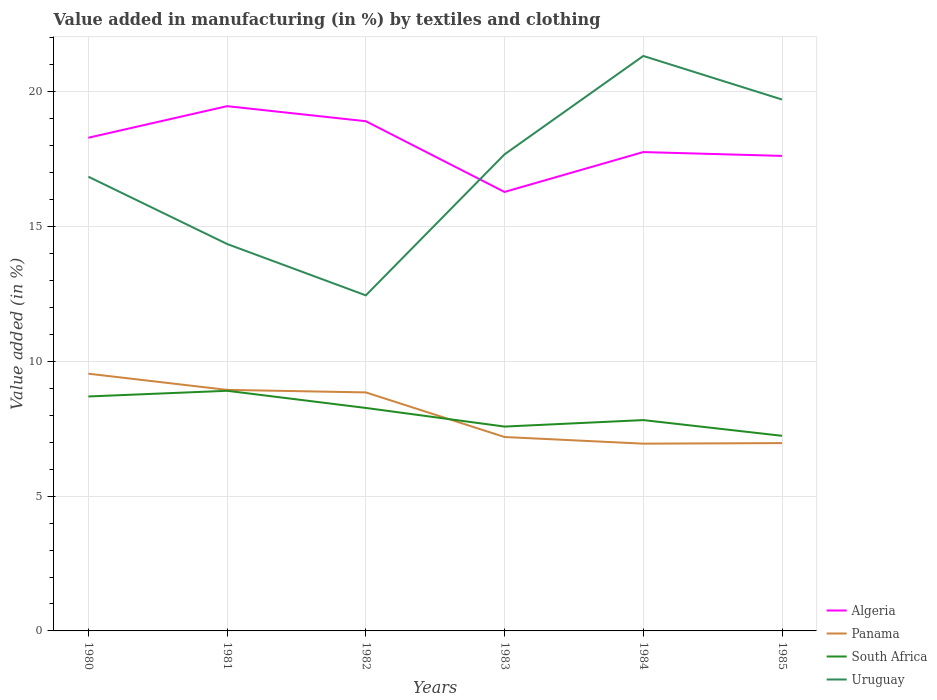Is the number of lines equal to the number of legend labels?
Provide a short and direct response. Yes. Across all years, what is the maximum percentage of value added in manufacturing by textiles and clothing in Algeria?
Offer a terse response. 16.29. In which year was the percentage of value added in manufacturing by textiles and clothing in South Africa maximum?
Provide a short and direct response. 1985. What is the total percentage of value added in manufacturing by textiles and clothing in Uruguay in the graph?
Your answer should be compact. 1.62. What is the difference between the highest and the second highest percentage of value added in manufacturing by textiles and clothing in Uruguay?
Provide a succinct answer. 8.88. What is the difference between two consecutive major ticks on the Y-axis?
Provide a succinct answer. 5. Does the graph contain any zero values?
Your response must be concise. No. Does the graph contain grids?
Your answer should be compact. Yes. How are the legend labels stacked?
Your response must be concise. Vertical. What is the title of the graph?
Offer a terse response. Value added in manufacturing (in %) by textiles and clothing. Does "European Union" appear as one of the legend labels in the graph?
Provide a succinct answer. No. What is the label or title of the Y-axis?
Keep it short and to the point. Value added (in %). What is the Value added (in %) of Algeria in 1980?
Offer a very short reply. 18.3. What is the Value added (in %) in Panama in 1980?
Offer a terse response. 9.54. What is the Value added (in %) of South Africa in 1980?
Ensure brevity in your answer.  8.7. What is the Value added (in %) of Uruguay in 1980?
Keep it short and to the point. 16.85. What is the Value added (in %) of Algeria in 1981?
Your response must be concise. 19.47. What is the Value added (in %) in Panama in 1981?
Make the answer very short. 8.94. What is the Value added (in %) of South Africa in 1981?
Your response must be concise. 8.91. What is the Value added (in %) of Uruguay in 1981?
Your response must be concise. 14.35. What is the Value added (in %) of Algeria in 1982?
Give a very brief answer. 18.91. What is the Value added (in %) in Panama in 1982?
Ensure brevity in your answer.  8.85. What is the Value added (in %) of South Africa in 1982?
Your answer should be very brief. 8.27. What is the Value added (in %) in Uruguay in 1982?
Ensure brevity in your answer.  12.45. What is the Value added (in %) of Algeria in 1983?
Keep it short and to the point. 16.29. What is the Value added (in %) of Panama in 1983?
Provide a succinct answer. 7.19. What is the Value added (in %) of South Africa in 1983?
Offer a very short reply. 7.58. What is the Value added (in %) of Uruguay in 1983?
Offer a terse response. 17.68. What is the Value added (in %) of Algeria in 1984?
Give a very brief answer. 17.76. What is the Value added (in %) of Panama in 1984?
Your response must be concise. 6.95. What is the Value added (in %) in South Africa in 1984?
Provide a succinct answer. 7.82. What is the Value added (in %) in Uruguay in 1984?
Your response must be concise. 21.33. What is the Value added (in %) of Algeria in 1985?
Make the answer very short. 17.62. What is the Value added (in %) of Panama in 1985?
Ensure brevity in your answer.  6.97. What is the Value added (in %) of South Africa in 1985?
Make the answer very short. 7.24. What is the Value added (in %) in Uruguay in 1985?
Provide a succinct answer. 19.71. Across all years, what is the maximum Value added (in %) in Algeria?
Keep it short and to the point. 19.47. Across all years, what is the maximum Value added (in %) in Panama?
Provide a succinct answer. 9.54. Across all years, what is the maximum Value added (in %) of South Africa?
Your response must be concise. 8.91. Across all years, what is the maximum Value added (in %) of Uruguay?
Your answer should be compact. 21.33. Across all years, what is the minimum Value added (in %) in Algeria?
Provide a short and direct response. 16.29. Across all years, what is the minimum Value added (in %) in Panama?
Your answer should be very brief. 6.95. Across all years, what is the minimum Value added (in %) of South Africa?
Keep it short and to the point. 7.24. Across all years, what is the minimum Value added (in %) of Uruguay?
Keep it short and to the point. 12.45. What is the total Value added (in %) in Algeria in the graph?
Give a very brief answer. 108.35. What is the total Value added (in %) in Panama in the graph?
Provide a succinct answer. 48.44. What is the total Value added (in %) of South Africa in the graph?
Offer a very short reply. 48.52. What is the total Value added (in %) in Uruguay in the graph?
Your answer should be very brief. 102.38. What is the difference between the Value added (in %) in Algeria in 1980 and that in 1981?
Ensure brevity in your answer.  -1.17. What is the difference between the Value added (in %) of Panama in 1980 and that in 1981?
Give a very brief answer. 0.6. What is the difference between the Value added (in %) in South Africa in 1980 and that in 1981?
Offer a very short reply. -0.21. What is the difference between the Value added (in %) in Uruguay in 1980 and that in 1981?
Your answer should be very brief. 2.5. What is the difference between the Value added (in %) of Algeria in 1980 and that in 1982?
Give a very brief answer. -0.61. What is the difference between the Value added (in %) in Panama in 1980 and that in 1982?
Keep it short and to the point. 0.69. What is the difference between the Value added (in %) of South Africa in 1980 and that in 1982?
Keep it short and to the point. 0.43. What is the difference between the Value added (in %) in Uruguay in 1980 and that in 1982?
Your answer should be very brief. 4.4. What is the difference between the Value added (in %) in Algeria in 1980 and that in 1983?
Give a very brief answer. 2.01. What is the difference between the Value added (in %) in Panama in 1980 and that in 1983?
Make the answer very short. 2.35. What is the difference between the Value added (in %) in South Africa in 1980 and that in 1983?
Ensure brevity in your answer.  1.12. What is the difference between the Value added (in %) in Uruguay in 1980 and that in 1983?
Provide a short and direct response. -0.83. What is the difference between the Value added (in %) of Algeria in 1980 and that in 1984?
Keep it short and to the point. 0.53. What is the difference between the Value added (in %) in Panama in 1980 and that in 1984?
Your answer should be compact. 2.6. What is the difference between the Value added (in %) of South Africa in 1980 and that in 1984?
Provide a succinct answer. 0.88. What is the difference between the Value added (in %) of Uruguay in 1980 and that in 1984?
Provide a succinct answer. -4.48. What is the difference between the Value added (in %) of Algeria in 1980 and that in 1985?
Ensure brevity in your answer.  0.67. What is the difference between the Value added (in %) of Panama in 1980 and that in 1985?
Your answer should be compact. 2.57. What is the difference between the Value added (in %) of South Africa in 1980 and that in 1985?
Offer a terse response. 1.46. What is the difference between the Value added (in %) of Uruguay in 1980 and that in 1985?
Give a very brief answer. -2.86. What is the difference between the Value added (in %) of Algeria in 1981 and that in 1982?
Offer a very short reply. 0.56. What is the difference between the Value added (in %) in Panama in 1981 and that in 1982?
Make the answer very short. 0.09. What is the difference between the Value added (in %) of South Africa in 1981 and that in 1982?
Offer a very short reply. 0.64. What is the difference between the Value added (in %) in Uruguay in 1981 and that in 1982?
Your answer should be compact. 1.91. What is the difference between the Value added (in %) of Algeria in 1981 and that in 1983?
Offer a terse response. 3.18. What is the difference between the Value added (in %) in Panama in 1981 and that in 1983?
Offer a terse response. 1.75. What is the difference between the Value added (in %) of South Africa in 1981 and that in 1983?
Give a very brief answer. 1.33. What is the difference between the Value added (in %) in Uruguay in 1981 and that in 1983?
Make the answer very short. -3.33. What is the difference between the Value added (in %) in Algeria in 1981 and that in 1984?
Your answer should be compact. 1.7. What is the difference between the Value added (in %) in Panama in 1981 and that in 1984?
Ensure brevity in your answer.  2. What is the difference between the Value added (in %) of South Africa in 1981 and that in 1984?
Keep it short and to the point. 1.09. What is the difference between the Value added (in %) in Uruguay in 1981 and that in 1984?
Your response must be concise. -6.98. What is the difference between the Value added (in %) of Algeria in 1981 and that in 1985?
Give a very brief answer. 1.84. What is the difference between the Value added (in %) of Panama in 1981 and that in 1985?
Provide a succinct answer. 1.97. What is the difference between the Value added (in %) of South Africa in 1981 and that in 1985?
Keep it short and to the point. 1.67. What is the difference between the Value added (in %) in Uruguay in 1981 and that in 1985?
Give a very brief answer. -5.36. What is the difference between the Value added (in %) in Algeria in 1982 and that in 1983?
Provide a succinct answer. 2.62. What is the difference between the Value added (in %) of Panama in 1982 and that in 1983?
Your answer should be very brief. 1.65. What is the difference between the Value added (in %) in South Africa in 1982 and that in 1983?
Provide a succinct answer. 0.69. What is the difference between the Value added (in %) in Uruguay in 1982 and that in 1983?
Offer a terse response. -5.23. What is the difference between the Value added (in %) in Algeria in 1982 and that in 1984?
Your response must be concise. 1.14. What is the difference between the Value added (in %) in Panama in 1982 and that in 1984?
Ensure brevity in your answer.  1.9. What is the difference between the Value added (in %) of South Africa in 1982 and that in 1984?
Offer a terse response. 0.45. What is the difference between the Value added (in %) in Uruguay in 1982 and that in 1984?
Make the answer very short. -8.88. What is the difference between the Value added (in %) of Algeria in 1982 and that in 1985?
Make the answer very short. 1.29. What is the difference between the Value added (in %) of Panama in 1982 and that in 1985?
Offer a very short reply. 1.88. What is the difference between the Value added (in %) of South Africa in 1982 and that in 1985?
Offer a very short reply. 1.03. What is the difference between the Value added (in %) of Uruguay in 1982 and that in 1985?
Your answer should be very brief. -7.26. What is the difference between the Value added (in %) of Algeria in 1983 and that in 1984?
Provide a succinct answer. -1.48. What is the difference between the Value added (in %) in Panama in 1983 and that in 1984?
Make the answer very short. 0.25. What is the difference between the Value added (in %) in South Africa in 1983 and that in 1984?
Keep it short and to the point. -0.24. What is the difference between the Value added (in %) in Uruguay in 1983 and that in 1984?
Your answer should be very brief. -3.65. What is the difference between the Value added (in %) of Algeria in 1983 and that in 1985?
Offer a very short reply. -1.34. What is the difference between the Value added (in %) of Panama in 1983 and that in 1985?
Provide a succinct answer. 0.23. What is the difference between the Value added (in %) in South Africa in 1983 and that in 1985?
Provide a short and direct response. 0.34. What is the difference between the Value added (in %) in Uruguay in 1983 and that in 1985?
Offer a terse response. -2.03. What is the difference between the Value added (in %) in Algeria in 1984 and that in 1985?
Offer a very short reply. 0.14. What is the difference between the Value added (in %) in Panama in 1984 and that in 1985?
Offer a very short reply. -0.02. What is the difference between the Value added (in %) in South Africa in 1984 and that in 1985?
Make the answer very short. 0.58. What is the difference between the Value added (in %) of Uruguay in 1984 and that in 1985?
Provide a succinct answer. 1.62. What is the difference between the Value added (in %) in Algeria in 1980 and the Value added (in %) in Panama in 1981?
Ensure brevity in your answer.  9.35. What is the difference between the Value added (in %) in Algeria in 1980 and the Value added (in %) in South Africa in 1981?
Offer a very short reply. 9.39. What is the difference between the Value added (in %) in Algeria in 1980 and the Value added (in %) in Uruguay in 1981?
Your response must be concise. 3.94. What is the difference between the Value added (in %) of Panama in 1980 and the Value added (in %) of South Africa in 1981?
Provide a succinct answer. 0.63. What is the difference between the Value added (in %) in Panama in 1980 and the Value added (in %) in Uruguay in 1981?
Give a very brief answer. -4.81. What is the difference between the Value added (in %) in South Africa in 1980 and the Value added (in %) in Uruguay in 1981?
Ensure brevity in your answer.  -5.66. What is the difference between the Value added (in %) of Algeria in 1980 and the Value added (in %) of Panama in 1982?
Offer a very short reply. 9.45. What is the difference between the Value added (in %) in Algeria in 1980 and the Value added (in %) in South Africa in 1982?
Offer a terse response. 10.02. What is the difference between the Value added (in %) of Algeria in 1980 and the Value added (in %) of Uruguay in 1982?
Make the answer very short. 5.85. What is the difference between the Value added (in %) in Panama in 1980 and the Value added (in %) in South Africa in 1982?
Your response must be concise. 1.27. What is the difference between the Value added (in %) of Panama in 1980 and the Value added (in %) of Uruguay in 1982?
Ensure brevity in your answer.  -2.91. What is the difference between the Value added (in %) of South Africa in 1980 and the Value added (in %) of Uruguay in 1982?
Provide a succinct answer. -3.75. What is the difference between the Value added (in %) in Algeria in 1980 and the Value added (in %) in Panama in 1983?
Offer a terse response. 11.1. What is the difference between the Value added (in %) of Algeria in 1980 and the Value added (in %) of South Africa in 1983?
Your answer should be compact. 10.72. What is the difference between the Value added (in %) in Algeria in 1980 and the Value added (in %) in Uruguay in 1983?
Provide a short and direct response. 0.62. What is the difference between the Value added (in %) of Panama in 1980 and the Value added (in %) of South Africa in 1983?
Keep it short and to the point. 1.96. What is the difference between the Value added (in %) of Panama in 1980 and the Value added (in %) of Uruguay in 1983?
Offer a terse response. -8.14. What is the difference between the Value added (in %) in South Africa in 1980 and the Value added (in %) in Uruguay in 1983?
Give a very brief answer. -8.98. What is the difference between the Value added (in %) of Algeria in 1980 and the Value added (in %) of Panama in 1984?
Offer a very short reply. 11.35. What is the difference between the Value added (in %) of Algeria in 1980 and the Value added (in %) of South Africa in 1984?
Offer a very short reply. 10.47. What is the difference between the Value added (in %) in Algeria in 1980 and the Value added (in %) in Uruguay in 1984?
Your response must be concise. -3.03. What is the difference between the Value added (in %) of Panama in 1980 and the Value added (in %) of South Africa in 1984?
Provide a short and direct response. 1.72. What is the difference between the Value added (in %) in Panama in 1980 and the Value added (in %) in Uruguay in 1984?
Your response must be concise. -11.79. What is the difference between the Value added (in %) of South Africa in 1980 and the Value added (in %) of Uruguay in 1984?
Your answer should be compact. -12.63. What is the difference between the Value added (in %) of Algeria in 1980 and the Value added (in %) of Panama in 1985?
Make the answer very short. 11.33. What is the difference between the Value added (in %) in Algeria in 1980 and the Value added (in %) in South Africa in 1985?
Keep it short and to the point. 11.06. What is the difference between the Value added (in %) in Algeria in 1980 and the Value added (in %) in Uruguay in 1985?
Offer a terse response. -1.42. What is the difference between the Value added (in %) in Panama in 1980 and the Value added (in %) in South Africa in 1985?
Offer a terse response. 2.3. What is the difference between the Value added (in %) of Panama in 1980 and the Value added (in %) of Uruguay in 1985?
Offer a very short reply. -10.17. What is the difference between the Value added (in %) in South Africa in 1980 and the Value added (in %) in Uruguay in 1985?
Your answer should be very brief. -11.02. What is the difference between the Value added (in %) in Algeria in 1981 and the Value added (in %) in Panama in 1982?
Give a very brief answer. 10.62. What is the difference between the Value added (in %) of Algeria in 1981 and the Value added (in %) of South Africa in 1982?
Ensure brevity in your answer.  11.2. What is the difference between the Value added (in %) in Algeria in 1981 and the Value added (in %) in Uruguay in 1982?
Provide a short and direct response. 7.02. What is the difference between the Value added (in %) of Panama in 1981 and the Value added (in %) of South Africa in 1982?
Your answer should be compact. 0.67. What is the difference between the Value added (in %) in Panama in 1981 and the Value added (in %) in Uruguay in 1982?
Your answer should be very brief. -3.51. What is the difference between the Value added (in %) in South Africa in 1981 and the Value added (in %) in Uruguay in 1982?
Your response must be concise. -3.54. What is the difference between the Value added (in %) in Algeria in 1981 and the Value added (in %) in Panama in 1983?
Provide a short and direct response. 12.27. What is the difference between the Value added (in %) in Algeria in 1981 and the Value added (in %) in South Africa in 1983?
Provide a short and direct response. 11.89. What is the difference between the Value added (in %) of Algeria in 1981 and the Value added (in %) of Uruguay in 1983?
Provide a short and direct response. 1.79. What is the difference between the Value added (in %) of Panama in 1981 and the Value added (in %) of South Africa in 1983?
Give a very brief answer. 1.36. What is the difference between the Value added (in %) in Panama in 1981 and the Value added (in %) in Uruguay in 1983?
Your answer should be compact. -8.74. What is the difference between the Value added (in %) of South Africa in 1981 and the Value added (in %) of Uruguay in 1983?
Give a very brief answer. -8.77. What is the difference between the Value added (in %) of Algeria in 1981 and the Value added (in %) of Panama in 1984?
Your answer should be compact. 12.52. What is the difference between the Value added (in %) in Algeria in 1981 and the Value added (in %) in South Africa in 1984?
Provide a succinct answer. 11.65. What is the difference between the Value added (in %) in Algeria in 1981 and the Value added (in %) in Uruguay in 1984?
Your answer should be compact. -1.86. What is the difference between the Value added (in %) of Panama in 1981 and the Value added (in %) of South Africa in 1984?
Ensure brevity in your answer.  1.12. What is the difference between the Value added (in %) of Panama in 1981 and the Value added (in %) of Uruguay in 1984?
Make the answer very short. -12.39. What is the difference between the Value added (in %) in South Africa in 1981 and the Value added (in %) in Uruguay in 1984?
Ensure brevity in your answer.  -12.42. What is the difference between the Value added (in %) in Algeria in 1981 and the Value added (in %) in Panama in 1985?
Keep it short and to the point. 12.5. What is the difference between the Value added (in %) of Algeria in 1981 and the Value added (in %) of South Africa in 1985?
Provide a short and direct response. 12.23. What is the difference between the Value added (in %) in Algeria in 1981 and the Value added (in %) in Uruguay in 1985?
Make the answer very short. -0.25. What is the difference between the Value added (in %) in Panama in 1981 and the Value added (in %) in South Africa in 1985?
Your answer should be very brief. 1.7. What is the difference between the Value added (in %) in Panama in 1981 and the Value added (in %) in Uruguay in 1985?
Provide a succinct answer. -10.77. What is the difference between the Value added (in %) in South Africa in 1981 and the Value added (in %) in Uruguay in 1985?
Your response must be concise. -10.81. What is the difference between the Value added (in %) in Algeria in 1982 and the Value added (in %) in Panama in 1983?
Your response must be concise. 11.72. What is the difference between the Value added (in %) of Algeria in 1982 and the Value added (in %) of South Africa in 1983?
Provide a succinct answer. 11.33. What is the difference between the Value added (in %) of Algeria in 1982 and the Value added (in %) of Uruguay in 1983?
Your answer should be very brief. 1.23. What is the difference between the Value added (in %) in Panama in 1982 and the Value added (in %) in South Africa in 1983?
Keep it short and to the point. 1.27. What is the difference between the Value added (in %) in Panama in 1982 and the Value added (in %) in Uruguay in 1983?
Provide a succinct answer. -8.83. What is the difference between the Value added (in %) of South Africa in 1982 and the Value added (in %) of Uruguay in 1983?
Give a very brief answer. -9.41. What is the difference between the Value added (in %) in Algeria in 1982 and the Value added (in %) in Panama in 1984?
Ensure brevity in your answer.  11.96. What is the difference between the Value added (in %) in Algeria in 1982 and the Value added (in %) in South Africa in 1984?
Ensure brevity in your answer.  11.09. What is the difference between the Value added (in %) in Algeria in 1982 and the Value added (in %) in Uruguay in 1984?
Offer a terse response. -2.42. What is the difference between the Value added (in %) in Panama in 1982 and the Value added (in %) in South Africa in 1984?
Offer a terse response. 1.03. What is the difference between the Value added (in %) in Panama in 1982 and the Value added (in %) in Uruguay in 1984?
Your response must be concise. -12.48. What is the difference between the Value added (in %) of South Africa in 1982 and the Value added (in %) of Uruguay in 1984?
Ensure brevity in your answer.  -13.06. What is the difference between the Value added (in %) of Algeria in 1982 and the Value added (in %) of Panama in 1985?
Offer a terse response. 11.94. What is the difference between the Value added (in %) in Algeria in 1982 and the Value added (in %) in South Africa in 1985?
Provide a succinct answer. 11.67. What is the difference between the Value added (in %) of Algeria in 1982 and the Value added (in %) of Uruguay in 1985?
Offer a very short reply. -0.8. What is the difference between the Value added (in %) in Panama in 1982 and the Value added (in %) in South Africa in 1985?
Keep it short and to the point. 1.61. What is the difference between the Value added (in %) of Panama in 1982 and the Value added (in %) of Uruguay in 1985?
Your answer should be very brief. -10.87. What is the difference between the Value added (in %) of South Africa in 1982 and the Value added (in %) of Uruguay in 1985?
Your answer should be compact. -11.44. What is the difference between the Value added (in %) in Algeria in 1983 and the Value added (in %) in Panama in 1984?
Your response must be concise. 9.34. What is the difference between the Value added (in %) in Algeria in 1983 and the Value added (in %) in South Africa in 1984?
Offer a very short reply. 8.46. What is the difference between the Value added (in %) in Algeria in 1983 and the Value added (in %) in Uruguay in 1984?
Ensure brevity in your answer.  -5.04. What is the difference between the Value added (in %) of Panama in 1983 and the Value added (in %) of South Africa in 1984?
Your answer should be very brief. -0.63. What is the difference between the Value added (in %) of Panama in 1983 and the Value added (in %) of Uruguay in 1984?
Keep it short and to the point. -14.14. What is the difference between the Value added (in %) in South Africa in 1983 and the Value added (in %) in Uruguay in 1984?
Your response must be concise. -13.75. What is the difference between the Value added (in %) in Algeria in 1983 and the Value added (in %) in Panama in 1985?
Offer a terse response. 9.32. What is the difference between the Value added (in %) in Algeria in 1983 and the Value added (in %) in South Africa in 1985?
Give a very brief answer. 9.05. What is the difference between the Value added (in %) of Algeria in 1983 and the Value added (in %) of Uruguay in 1985?
Offer a very short reply. -3.43. What is the difference between the Value added (in %) in Panama in 1983 and the Value added (in %) in South Africa in 1985?
Provide a short and direct response. -0.04. What is the difference between the Value added (in %) of Panama in 1983 and the Value added (in %) of Uruguay in 1985?
Ensure brevity in your answer.  -12.52. What is the difference between the Value added (in %) of South Africa in 1983 and the Value added (in %) of Uruguay in 1985?
Keep it short and to the point. -12.13. What is the difference between the Value added (in %) of Algeria in 1984 and the Value added (in %) of Panama in 1985?
Your answer should be compact. 10.8. What is the difference between the Value added (in %) of Algeria in 1984 and the Value added (in %) of South Africa in 1985?
Provide a short and direct response. 10.53. What is the difference between the Value added (in %) in Algeria in 1984 and the Value added (in %) in Uruguay in 1985?
Your response must be concise. -1.95. What is the difference between the Value added (in %) in Panama in 1984 and the Value added (in %) in South Africa in 1985?
Offer a terse response. -0.29. What is the difference between the Value added (in %) of Panama in 1984 and the Value added (in %) of Uruguay in 1985?
Provide a succinct answer. -12.77. What is the difference between the Value added (in %) in South Africa in 1984 and the Value added (in %) in Uruguay in 1985?
Your response must be concise. -11.89. What is the average Value added (in %) of Algeria per year?
Give a very brief answer. 18.06. What is the average Value added (in %) of Panama per year?
Offer a terse response. 8.07. What is the average Value added (in %) of South Africa per year?
Give a very brief answer. 8.09. What is the average Value added (in %) in Uruguay per year?
Your answer should be very brief. 17.06. In the year 1980, what is the difference between the Value added (in %) in Algeria and Value added (in %) in Panama?
Provide a short and direct response. 8.75. In the year 1980, what is the difference between the Value added (in %) in Algeria and Value added (in %) in South Africa?
Provide a short and direct response. 9.6. In the year 1980, what is the difference between the Value added (in %) in Algeria and Value added (in %) in Uruguay?
Keep it short and to the point. 1.45. In the year 1980, what is the difference between the Value added (in %) of Panama and Value added (in %) of South Africa?
Offer a very short reply. 0.84. In the year 1980, what is the difference between the Value added (in %) of Panama and Value added (in %) of Uruguay?
Give a very brief answer. -7.31. In the year 1980, what is the difference between the Value added (in %) in South Africa and Value added (in %) in Uruguay?
Provide a succinct answer. -8.15. In the year 1981, what is the difference between the Value added (in %) of Algeria and Value added (in %) of Panama?
Offer a very short reply. 10.53. In the year 1981, what is the difference between the Value added (in %) of Algeria and Value added (in %) of South Africa?
Provide a short and direct response. 10.56. In the year 1981, what is the difference between the Value added (in %) in Algeria and Value added (in %) in Uruguay?
Your response must be concise. 5.11. In the year 1981, what is the difference between the Value added (in %) in Panama and Value added (in %) in South Africa?
Ensure brevity in your answer.  0.03. In the year 1981, what is the difference between the Value added (in %) in Panama and Value added (in %) in Uruguay?
Offer a terse response. -5.41. In the year 1981, what is the difference between the Value added (in %) of South Africa and Value added (in %) of Uruguay?
Your answer should be compact. -5.45. In the year 1982, what is the difference between the Value added (in %) in Algeria and Value added (in %) in Panama?
Offer a terse response. 10.06. In the year 1982, what is the difference between the Value added (in %) in Algeria and Value added (in %) in South Africa?
Give a very brief answer. 10.64. In the year 1982, what is the difference between the Value added (in %) in Algeria and Value added (in %) in Uruguay?
Keep it short and to the point. 6.46. In the year 1982, what is the difference between the Value added (in %) of Panama and Value added (in %) of South Africa?
Ensure brevity in your answer.  0.58. In the year 1982, what is the difference between the Value added (in %) of Panama and Value added (in %) of Uruguay?
Your response must be concise. -3.6. In the year 1982, what is the difference between the Value added (in %) in South Africa and Value added (in %) in Uruguay?
Your response must be concise. -4.18. In the year 1983, what is the difference between the Value added (in %) of Algeria and Value added (in %) of Panama?
Offer a very short reply. 9.09. In the year 1983, what is the difference between the Value added (in %) of Algeria and Value added (in %) of South Africa?
Provide a short and direct response. 8.7. In the year 1983, what is the difference between the Value added (in %) of Algeria and Value added (in %) of Uruguay?
Offer a terse response. -1.4. In the year 1983, what is the difference between the Value added (in %) in Panama and Value added (in %) in South Africa?
Give a very brief answer. -0.39. In the year 1983, what is the difference between the Value added (in %) in Panama and Value added (in %) in Uruguay?
Make the answer very short. -10.49. In the year 1983, what is the difference between the Value added (in %) in South Africa and Value added (in %) in Uruguay?
Your answer should be very brief. -10.1. In the year 1984, what is the difference between the Value added (in %) in Algeria and Value added (in %) in Panama?
Offer a very short reply. 10.82. In the year 1984, what is the difference between the Value added (in %) of Algeria and Value added (in %) of South Africa?
Your response must be concise. 9.94. In the year 1984, what is the difference between the Value added (in %) in Algeria and Value added (in %) in Uruguay?
Your answer should be compact. -3.57. In the year 1984, what is the difference between the Value added (in %) of Panama and Value added (in %) of South Africa?
Offer a very short reply. -0.87. In the year 1984, what is the difference between the Value added (in %) of Panama and Value added (in %) of Uruguay?
Your response must be concise. -14.38. In the year 1984, what is the difference between the Value added (in %) of South Africa and Value added (in %) of Uruguay?
Offer a very short reply. -13.51. In the year 1985, what is the difference between the Value added (in %) in Algeria and Value added (in %) in Panama?
Your answer should be very brief. 10.65. In the year 1985, what is the difference between the Value added (in %) in Algeria and Value added (in %) in South Africa?
Ensure brevity in your answer.  10.38. In the year 1985, what is the difference between the Value added (in %) in Algeria and Value added (in %) in Uruguay?
Give a very brief answer. -2.09. In the year 1985, what is the difference between the Value added (in %) in Panama and Value added (in %) in South Africa?
Your answer should be compact. -0.27. In the year 1985, what is the difference between the Value added (in %) in Panama and Value added (in %) in Uruguay?
Your answer should be very brief. -12.75. In the year 1985, what is the difference between the Value added (in %) in South Africa and Value added (in %) in Uruguay?
Provide a short and direct response. -12.48. What is the ratio of the Value added (in %) in Algeria in 1980 to that in 1981?
Provide a short and direct response. 0.94. What is the ratio of the Value added (in %) in Panama in 1980 to that in 1981?
Offer a very short reply. 1.07. What is the ratio of the Value added (in %) in South Africa in 1980 to that in 1981?
Provide a succinct answer. 0.98. What is the ratio of the Value added (in %) in Uruguay in 1980 to that in 1981?
Provide a short and direct response. 1.17. What is the ratio of the Value added (in %) of Algeria in 1980 to that in 1982?
Your answer should be very brief. 0.97. What is the ratio of the Value added (in %) of Panama in 1980 to that in 1982?
Your response must be concise. 1.08. What is the ratio of the Value added (in %) of South Africa in 1980 to that in 1982?
Give a very brief answer. 1.05. What is the ratio of the Value added (in %) of Uruguay in 1980 to that in 1982?
Give a very brief answer. 1.35. What is the ratio of the Value added (in %) of Algeria in 1980 to that in 1983?
Provide a short and direct response. 1.12. What is the ratio of the Value added (in %) of Panama in 1980 to that in 1983?
Ensure brevity in your answer.  1.33. What is the ratio of the Value added (in %) in South Africa in 1980 to that in 1983?
Offer a terse response. 1.15. What is the ratio of the Value added (in %) in Uruguay in 1980 to that in 1983?
Offer a terse response. 0.95. What is the ratio of the Value added (in %) of Algeria in 1980 to that in 1984?
Your response must be concise. 1.03. What is the ratio of the Value added (in %) in Panama in 1980 to that in 1984?
Provide a succinct answer. 1.37. What is the ratio of the Value added (in %) in South Africa in 1980 to that in 1984?
Your response must be concise. 1.11. What is the ratio of the Value added (in %) of Uruguay in 1980 to that in 1984?
Ensure brevity in your answer.  0.79. What is the ratio of the Value added (in %) in Algeria in 1980 to that in 1985?
Your response must be concise. 1.04. What is the ratio of the Value added (in %) in Panama in 1980 to that in 1985?
Offer a very short reply. 1.37. What is the ratio of the Value added (in %) in South Africa in 1980 to that in 1985?
Ensure brevity in your answer.  1.2. What is the ratio of the Value added (in %) in Uruguay in 1980 to that in 1985?
Offer a very short reply. 0.85. What is the ratio of the Value added (in %) in Algeria in 1981 to that in 1982?
Ensure brevity in your answer.  1.03. What is the ratio of the Value added (in %) of Panama in 1981 to that in 1982?
Your answer should be very brief. 1.01. What is the ratio of the Value added (in %) of Uruguay in 1981 to that in 1982?
Your answer should be very brief. 1.15. What is the ratio of the Value added (in %) of Algeria in 1981 to that in 1983?
Offer a terse response. 1.2. What is the ratio of the Value added (in %) in Panama in 1981 to that in 1983?
Ensure brevity in your answer.  1.24. What is the ratio of the Value added (in %) in South Africa in 1981 to that in 1983?
Your answer should be compact. 1.18. What is the ratio of the Value added (in %) in Uruguay in 1981 to that in 1983?
Make the answer very short. 0.81. What is the ratio of the Value added (in %) in Algeria in 1981 to that in 1984?
Your response must be concise. 1.1. What is the ratio of the Value added (in %) of Panama in 1981 to that in 1984?
Your response must be concise. 1.29. What is the ratio of the Value added (in %) of South Africa in 1981 to that in 1984?
Provide a short and direct response. 1.14. What is the ratio of the Value added (in %) of Uruguay in 1981 to that in 1984?
Your response must be concise. 0.67. What is the ratio of the Value added (in %) of Algeria in 1981 to that in 1985?
Offer a very short reply. 1.1. What is the ratio of the Value added (in %) in Panama in 1981 to that in 1985?
Your response must be concise. 1.28. What is the ratio of the Value added (in %) of South Africa in 1981 to that in 1985?
Ensure brevity in your answer.  1.23. What is the ratio of the Value added (in %) of Uruguay in 1981 to that in 1985?
Your answer should be compact. 0.73. What is the ratio of the Value added (in %) of Algeria in 1982 to that in 1983?
Provide a succinct answer. 1.16. What is the ratio of the Value added (in %) in Panama in 1982 to that in 1983?
Give a very brief answer. 1.23. What is the ratio of the Value added (in %) in South Africa in 1982 to that in 1983?
Offer a very short reply. 1.09. What is the ratio of the Value added (in %) of Uruguay in 1982 to that in 1983?
Your response must be concise. 0.7. What is the ratio of the Value added (in %) in Algeria in 1982 to that in 1984?
Your answer should be compact. 1.06. What is the ratio of the Value added (in %) of Panama in 1982 to that in 1984?
Offer a terse response. 1.27. What is the ratio of the Value added (in %) in South Africa in 1982 to that in 1984?
Your response must be concise. 1.06. What is the ratio of the Value added (in %) in Uruguay in 1982 to that in 1984?
Provide a succinct answer. 0.58. What is the ratio of the Value added (in %) in Algeria in 1982 to that in 1985?
Offer a very short reply. 1.07. What is the ratio of the Value added (in %) of Panama in 1982 to that in 1985?
Keep it short and to the point. 1.27. What is the ratio of the Value added (in %) in South Africa in 1982 to that in 1985?
Ensure brevity in your answer.  1.14. What is the ratio of the Value added (in %) of Uruguay in 1982 to that in 1985?
Provide a short and direct response. 0.63. What is the ratio of the Value added (in %) of Algeria in 1983 to that in 1984?
Your response must be concise. 0.92. What is the ratio of the Value added (in %) of Panama in 1983 to that in 1984?
Ensure brevity in your answer.  1.04. What is the ratio of the Value added (in %) in South Africa in 1983 to that in 1984?
Your answer should be compact. 0.97. What is the ratio of the Value added (in %) of Uruguay in 1983 to that in 1984?
Keep it short and to the point. 0.83. What is the ratio of the Value added (in %) in Algeria in 1983 to that in 1985?
Provide a short and direct response. 0.92. What is the ratio of the Value added (in %) of Panama in 1983 to that in 1985?
Keep it short and to the point. 1.03. What is the ratio of the Value added (in %) in South Africa in 1983 to that in 1985?
Give a very brief answer. 1.05. What is the ratio of the Value added (in %) in Uruguay in 1983 to that in 1985?
Your answer should be very brief. 0.9. What is the ratio of the Value added (in %) in Algeria in 1984 to that in 1985?
Provide a short and direct response. 1.01. What is the ratio of the Value added (in %) in South Africa in 1984 to that in 1985?
Provide a short and direct response. 1.08. What is the ratio of the Value added (in %) in Uruguay in 1984 to that in 1985?
Provide a short and direct response. 1.08. What is the difference between the highest and the second highest Value added (in %) in Algeria?
Keep it short and to the point. 0.56. What is the difference between the highest and the second highest Value added (in %) in Panama?
Provide a short and direct response. 0.6. What is the difference between the highest and the second highest Value added (in %) in South Africa?
Your answer should be very brief. 0.21. What is the difference between the highest and the second highest Value added (in %) of Uruguay?
Provide a succinct answer. 1.62. What is the difference between the highest and the lowest Value added (in %) in Algeria?
Offer a terse response. 3.18. What is the difference between the highest and the lowest Value added (in %) in Panama?
Provide a short and direct response. 2.6. What is the difference between the highest and the lowest Value added (in %) of South Africa?
Your response must be concise. 1.67. What is the difference between the highest and the lowest Value added (in %) of Uruguay?
Offer a very short reply. 8.88. 